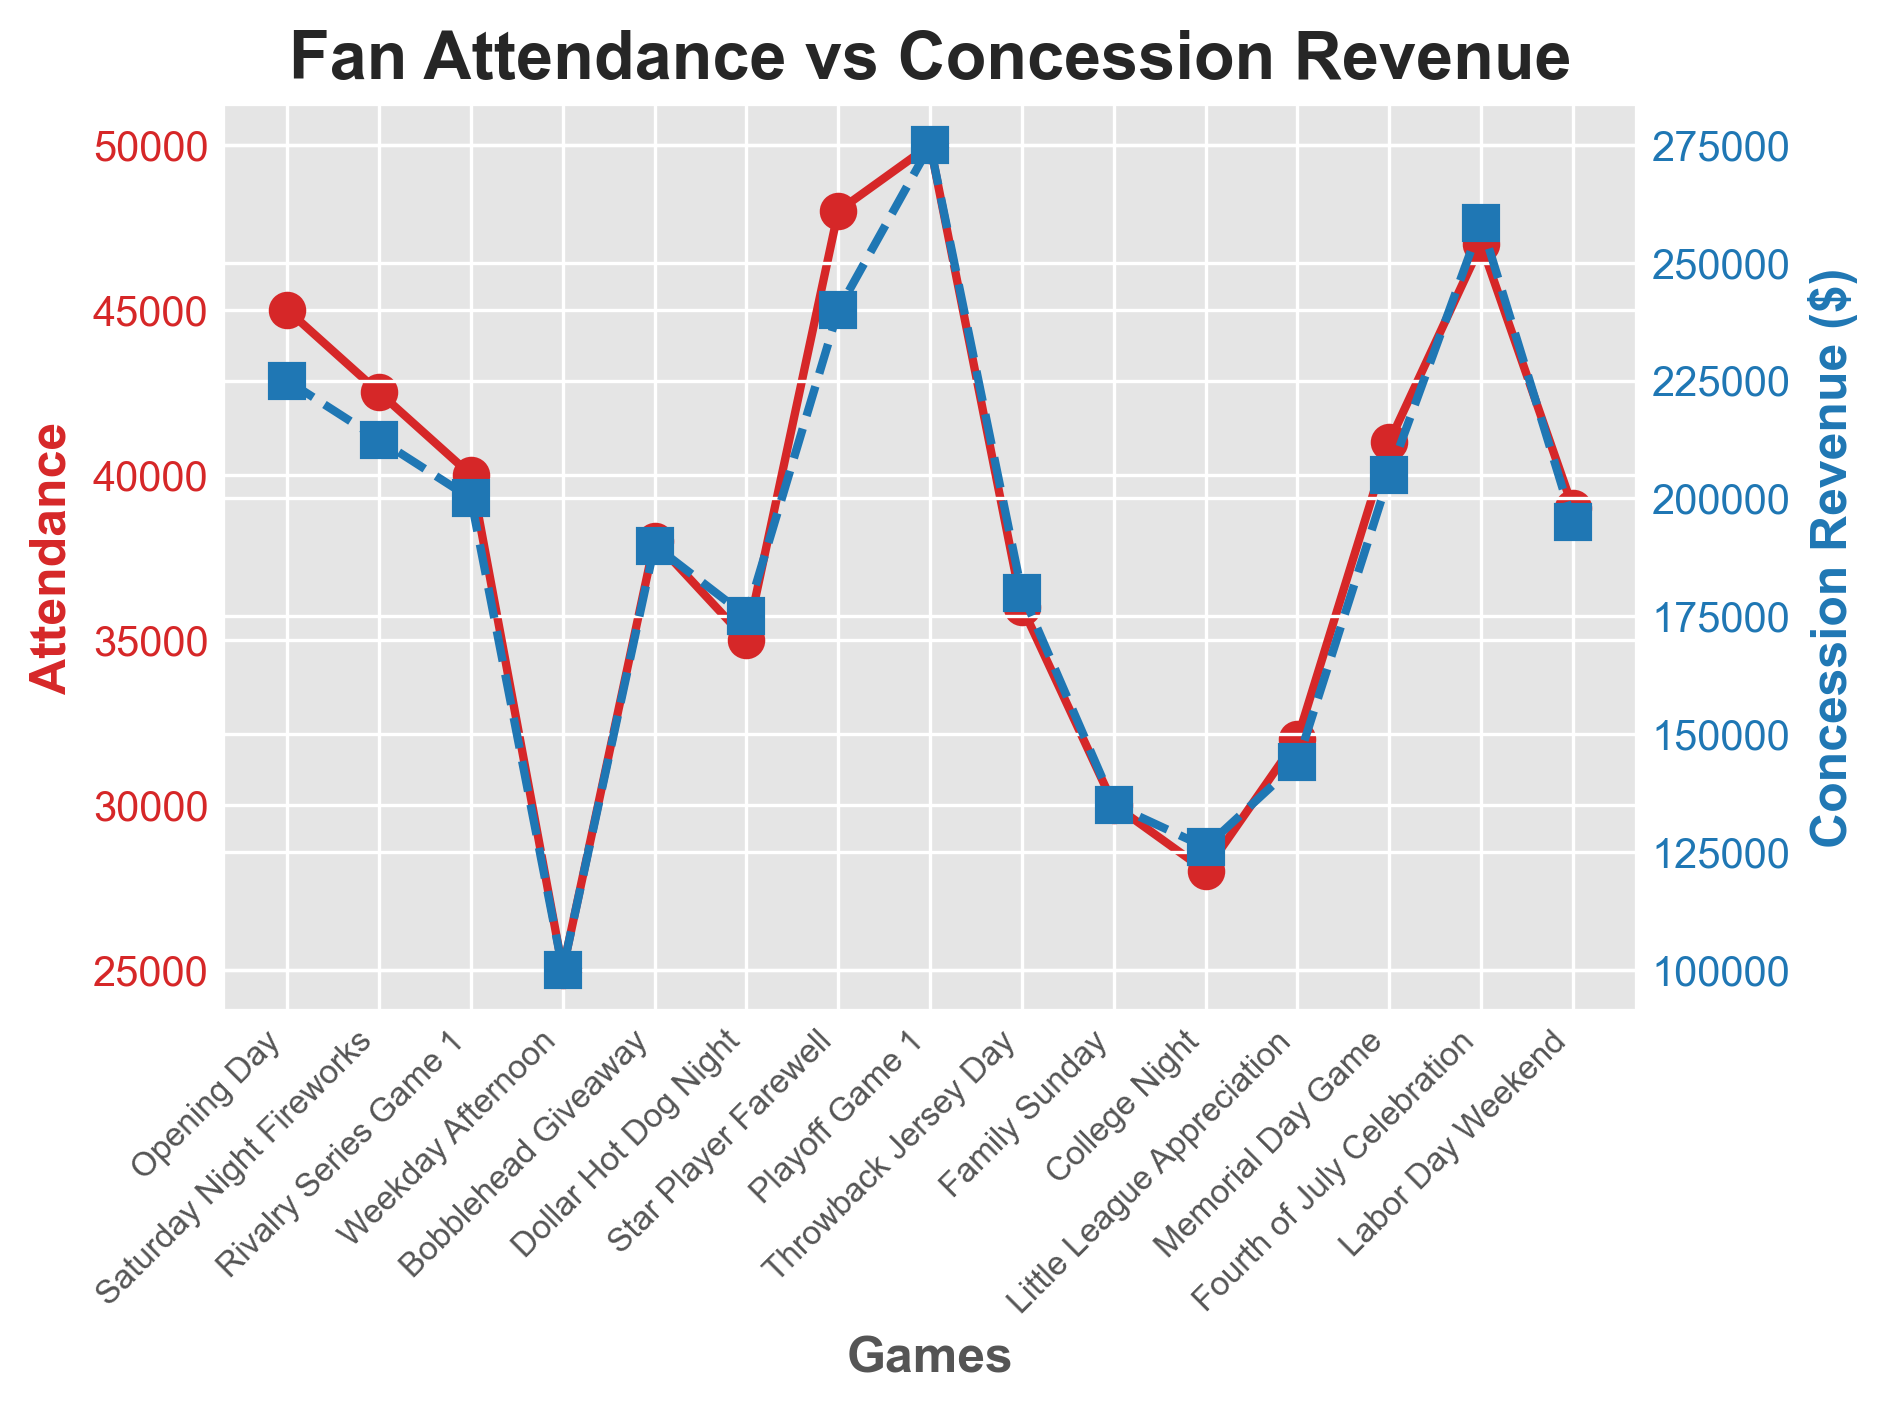Which game had the highest attendance? Look at the attendance line (in red) to identify the game with the highest peak. The highest attendance corresponds to the Playoff Game 1.
Answer: Playoff Game 1 Which game had lower attendance: Memorial Day Game or Little League Appreciation? Compare the attendance values of Memorial Day Game and Little League Appreciation. Memorial Day Game has higher attendance than Little League Appreciation.
Answer: Little League Appreciation What is the total concession revenue for Family Sunday and College Night combined? First, find the concession revenue for Family Sunday ($135,000) and College Night ($126,000). Then add them together: $135,000 + $126,000 = $261,000.
Answer: $261,000 Does the Dollar Hot Dog Night generate more revenue than the Weekday Afternoon game? Compare the concession revenue of Dollar Hot Dog Night ($175,000) and Weekday Afternoon ($100,000). Dollar Hot Dog Night generates more revenue.
Answer: Yes Is there a game where the attendance and concession revenue are both lower than the Star Player Farewell game? Identify the attendance (48,000) and concession revenue ($240,000) of the Star Player Farewell game. Check the other games to find data points where both values are lower. Little League Appreciation and several other games meet this condition.
Answer: Yes Which games have a concession revenue exceeding $250,000? Look at the concession revenue line (in blue) to identify peaks exceeding $250,000. The Playoff Game 1 and Fourth of July Celebration have revenues exceeding $250,000.
Answer: Playoff Game 1, Fourth of July Celebration What is the difference in attendance between Opening Day and Labor Day Weekend? Find the attendance of Opening Day (45,000) and Labor Day Weekend (39,000). Calculate the difference: 45,000 - 39,000 = 6,000.
Answer: 6,000 Which event had the lowest concession revenue and what was that amount? Find the point on the concession revenue line (in blue) that is the lowest. The Weekday Afternoon game had the lowest concession revenue of $100,000.
Answer: Weekday Afternoon, $100,000 What is the average attendance across all the games? Add all attendance values and divide by the number of games: (45000 + 42500 + 40000 + 25000 + 38000 + 35000 + 48000 + 50000 + 36000 + 30000 + 28000 + 32000 + 41000 + 47000 + 39000) / 15 = 37,900.
Answer: 37,900 What is the ratio of concession revenue to attendance for the Fourth of July Celebration? Find the concession revenue ($258,500) and attendance (47,000) for the Fourth of July Celebration and calculate the ratio: $258,500 / 47,000 ≈ 5.50.
Answer: 5.50 